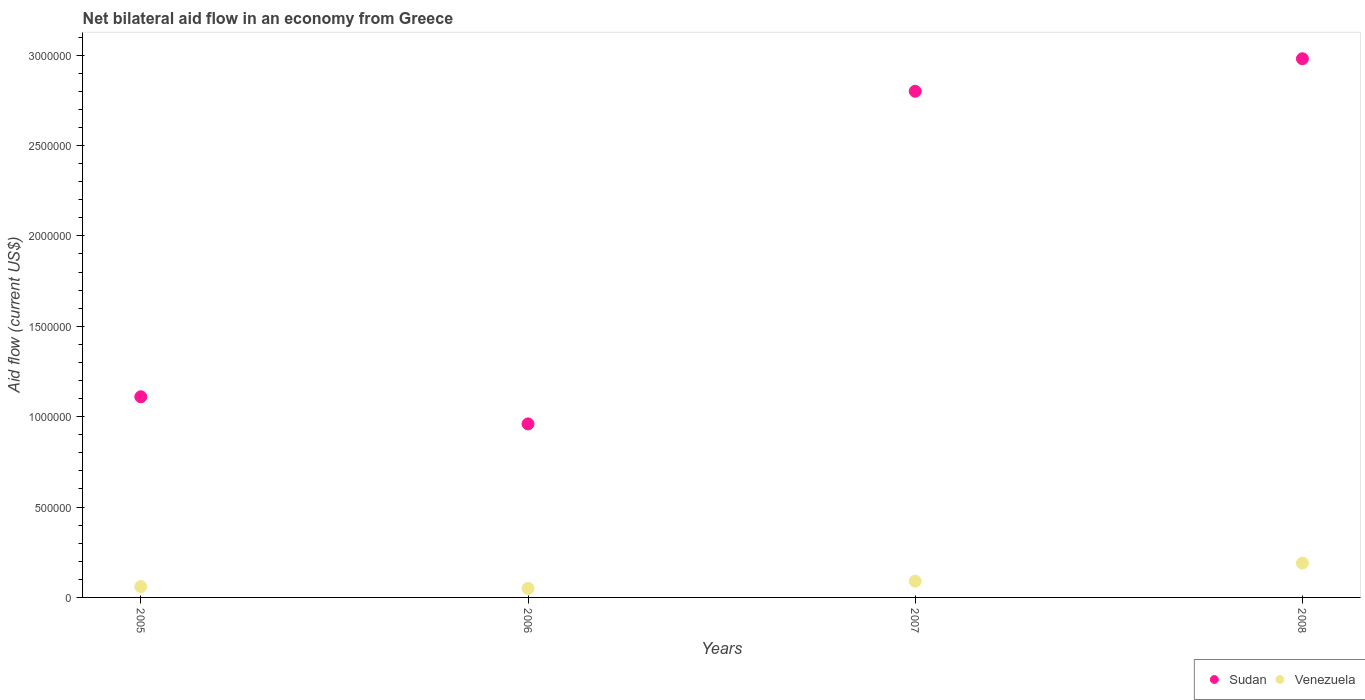Is the number of dotlines equal to the number of legend labels?
Offer a very short reply. Yes. What is the net bilateral aid flow in Sudan in 2006?
Offer a terse response. 9.60e+05. Across all years, what is the maximum net bilateral aid flow in Sudan?
Provide a short and direct response. 2.98e+06. Across all years, what is the minimum net bilateral aid flow in Venezuela?
Give a very brief answer. 5.00e+04. In which year was the net bilateral aid flow in Sudan maximum?
Your answer should be very brief. 2008. In which year was the net bilateral aid flow in Venezuela minimum?
Make the answer very short. 2006. What is the difference between the net bilateral aid flow in Venezuela in 2005 and that in 2006?
Give a very brief answer. 10000. What is the difference between the net bilateral aid flow in Sudan in 2006 and the net bilateral aid flow in Venezuela in 2007?
Make the answer very short. 8.70e+05. What is the average net bilateral aid flow in Venezuela per year?
Your response must be concise. 9.75e+04. In the year 2006, what is the difference between the net bilateral aid flow in Venezuela and net bilateral aid flow in Sudan?
Offer a very short reply. -9.10e+05. What is the ratio of the net bilateral aid flow in Sudan in 2005 to that in 2008?
Your response must be concise. 0.37. Is the net bilateral aid flow in Venezuela in 2005 less than that in 2006?
Give a very brief answer. No. Is the difference between the net bilateral aid flow in Venezuela in 2006 and 2007 greater than the difference between the net bilateral aid flow in Sudan in 2006 and 2007?
Your answer should be very brief. Yes. What is the difference between the highest and the second highest net bilateral aid flow in Venezuela?
Provide a succinct answer. 1.00e+05. Is the sum of the net bilateral aid flow in Venezuela in 2005 and 2007 greater than the maximum net bilateral aid flow in Sudan across all years?
Provide a short and direct response. No. Does the net bilateral aid flow in Venezuela monotonically increase over the years?
Keep it short and to the point. No. Is the net bilateral aid flow in Venezuela strictly greater than the net bilateral aid flow in Sudan over the years?
Ensure brevity in your answer.  No. How many dotlines are there?
Offer a terse response. 2. Where does the legend appear in the graph?
Offer a terse response. Bottom right. How are the legend labels stacked?
Keep it short and to the point. Horizontal. What is the title of the graph?
Give a very brief answer. Net bilateral aid flow in an economy from Greece. Does "Grenada" appear as one of the legend labels in the graph?
Offer a very short reply. No. What is the label or title of the Y-axis?
Your response must be concise. Aid flow (current US$). What is the Aid flow (current US$) of Sudan in 2005?
Your answer should be compact. 1.11e+06. What is the Aid flow (current US$) in Sudan in 2006?
Offer a terse response. 9.60e+05. What is the Aid flow (current US$) in Venezuela in 2006?
Provide a succinct answer. 5.00e+04. What is the Aid flow (current US$) of Sudan in 2007?
Your answer should be very brief. 2.80e+06. What is the Aid flow (current US$) in Sudan in 2008?
Offer a very short reply. 2.98e+06. Across all years, what is the maximum Aid flow (current US$) of Sudan?
Your response must be concise. 2.98e+06. Across all years, what is the minimum Aid flow (current US$) in Sudan?
Your answer should be compact. 9.60e+05. What is the total Aid flow (current US$) of Sudan in the graph?
Provide a succinct answer. 7.85e+06. What is the total Aid flow (current US$) of Venezuela in the graph?
Give a very brief answer. 3.90e+05. What is the difference between the Aid flow (current US$) in Sudan in 2005 and that in 2007?
Your response must be concise. -1.69e+06. What is the difference between the Aid flow (current US$) of Venezuela in 2005 and that in 2007?
Make the answer very short. -3.00e+04. What is the difference between the Aid flow (current US$) of Sudan in 2005 and that in 2008?
Provide a succinct answer. -1.87e+06. What is the difference between the Aid flow (current US$) in Venezuela in 2005 and that in 2008?
Your response must be concise. -1.30e+05. What is the difference between the Aid flow (current US$) of Sudan in 2006 and that in 2007?
Keep it short and to the point. -1.84e+06. What is the difference between the Aid flow (current US$) of Venezuela in 2006 and that in 2007?
Keep it short and to the point. -4.00e+04. What is the difference between the Aid flow (current US$) of Sudan in 2006 and that in 2008?
Your response must be concise. -2.02e+06. What is the difference between the Aid flow (current US$) of Venezuela in 2006 and that in 2008?
Your response must be concise. -1.40e+05. What is the difference between the Aid flow (current US$) of Sudan in 2005 and the Aid flow (current US$) of Venezuela in 2006?
Ensure brevity in your answer.  1.06e+06. What is the difference between the Aid flow (current US$) of Sudan in 2005 and the Aid flow (current US$) of Venezuela in 2007?
Your response must be concise. 1.02e+06. What is the difference between the Aid flow (current US$) of Sudan in 2005 and the Aid flow (current US$) of Venezuela in 2008?
Provide a short and direct response. 9.20e+05. What is the difference between the Aid flow (current US$) in Sudan in 2006 and the Aid flow (current US$) in Venezuela in 2007?
Your response must be concise. 8.70e+05. What is the difference between the Aid flow (current US$) in Sudan in 2006 and the Aid flow (current US$) in Venezuela in 2008?
Keep it short and to the point. 7.70e+05. What is the difference between the Aid flow (current US$) of Sudan in 2007 and the Aid flow (current US$) of Venezuela in 2008?
Ensure brevity in your answer.  2.61e+06. What is the average Aid flow (current US$) of Sudan per year?
Your answer should be very brief. 1.96e+06. What is the average Aid flow (current US$) of Venezuela per year?
Your answer should be compact. 9.75e+04. In the year 2005, what is the difference between the Aid flow (current US$) in Sudan and Aid flow (current US$) in Venezuela?
Your response must be concise. 1.05e+06. In the year 2006, what is the difference between the Aid flow (current US$) of Sudan and Aid flow (current US$) of Venezuela?
Ensure brevity in your answer.  9.10e+05. In the year 2007, what is the difference between the Aid flow (current US$) in Sudan and Aid flow (current US$) in Venezuela?
Offer a very short reply. 2.71e+06. In the year 2008, what is the difference between the Aid flow (current US$) of Sudan and Aid flow (current US$) of Venezuela?
Your answer should be compact. 2.79e+06. What is the ratio of the Aid flow (current US$) of Sudan in 2005 to that in 2006?
Give a very brief answer. 1.16. What is the ratio of the Aid flow (current US$) in Venezuela in 2005 to that in 2006?
Provide a succinct answer. 1.2. What is the ratio of the Aid flow (current US$) in Sudan in 2005 to that in 2007?
Provide a succinct answer. 0.4. What is the ratio of the Aid flow (current US$) of Venezuela in 2005 to that in 2007?
Give a very brief answer. 0.67. What is the ratio of the Aid flow (current US$) in Sudan in 2005 to that in 2008?
Ensure brevity in your answer.  0.37. What is the ratio of the Aid flow (current US$) in Venezuela in 2005 to that in 2008?
Provide a short and direct response. 0.32. What is the ratio of the Aid flow (current US$) in Sudan in 2006 to that in 2007?
Provide a succinct answer. 0.34. What is the ratio of the Aid flow (current US$) in Venezuela in 2006 to that in 2007?
Keep it short and to the point. 0.56. What is the ratio of the Aid flow (current US$) in Sudan in 2006 to that in 2008?
Offer a terse response. 0.32. What is the ratio of the Aid flow (current US$) of Venezuela in 2006 to that in 2008?
Offer a terse response. 0.26. What is the ratio of the Aid flow (current US$) of Sudan in 2007 to that in 2008?
Provide a succinct answer. 0.94. What is the ratio of the Aid flow (current US$) of Venezuela in 2007 to that in 2008?
Ensure brevity in your answer.  0.47. What is the difference between the highest and the second highest Aid flow (current US$) in Sudan?
Ensure brevity in your answer.  1.80e+05. What is the difference between the highest and the second highest Aid flow (current US$) of Venezuela?
Provide a short and direct response. 1.00e+05. What is the difference between the highest and the lowest Aid flow (current US$) in Sudan?
Your response must be concise. 2.02e+06. What is the difference between the highest and the lowest Aid flow (current US$) of Venezuela?
Offer a very short reply. 1.40e+05. 